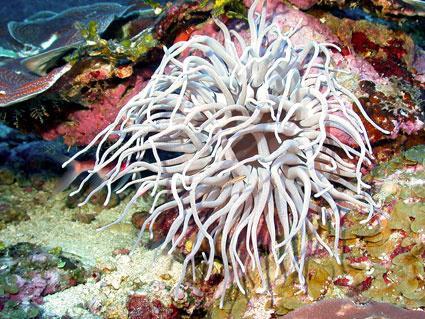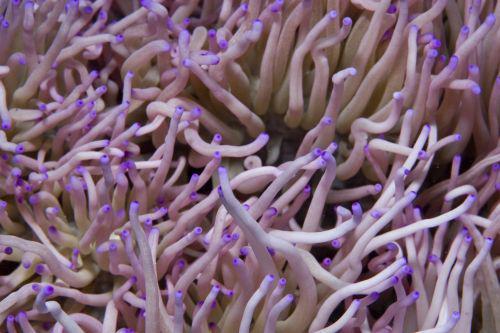The first image is the image on the left, the second image is the image on the right. For the images shown, is this caption "One image includes at least ten dark fish with white dots swimming above one large, pale, solid-colored anemone." true? Answer yes or no. No. The first image is the image on the left, the second image is the image on the right. For the images displayed, is the sentence "There are at least 10 small black and white fish swimming through corral." factually correct? Answer yes or no. No. 